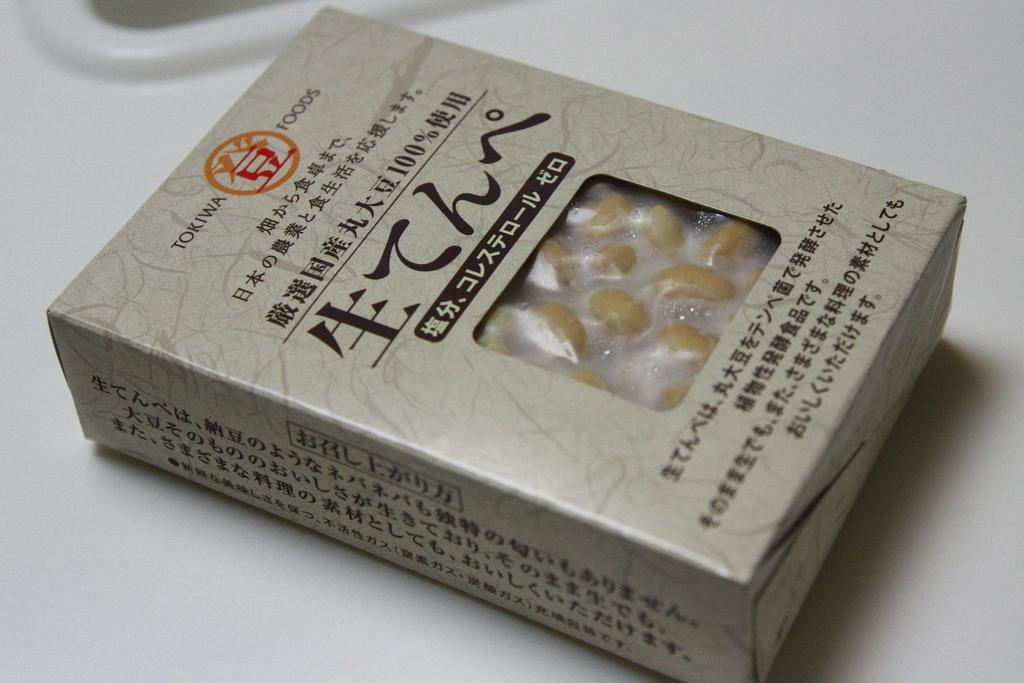What type of objects can be seen in the image? There are food items in the image. How are the food items arranged or contained? The food items are in a box. On what surface is the box placed? The box is placed on a white surface. What type of toys can be seen in the image? There are no toys present in the image; it features food items in a box on a white surface. 